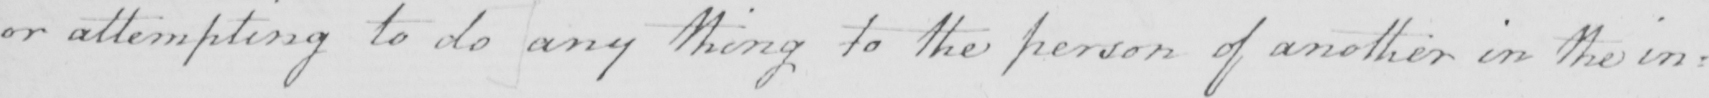What is written in this line of handwriting? or attempting to do any thing to the person of another in the in= 